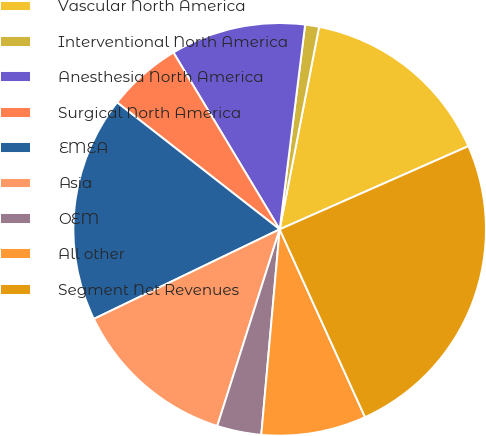Convert chart to OTSL. <chart><loc_0><loc_0><loc_500><loc_500><pie_chart><fcel>Vascular North America<fcel>Interventional North America<fcel>Anesthesia North America<fcel>Surgical North America<fcel>EMEA<fcel>Asia<fcel>OEM<fcel>All other<fcel>Segment Net Revenues<nl><fcel>15.33%<fcel>1.09%<fcel>10.58%<fcel>5.84%<fcel>17.7%<fcel>12.96%<fcel>3.47%<fcel>8.21%<fcel>24.82%<nl></chart> 